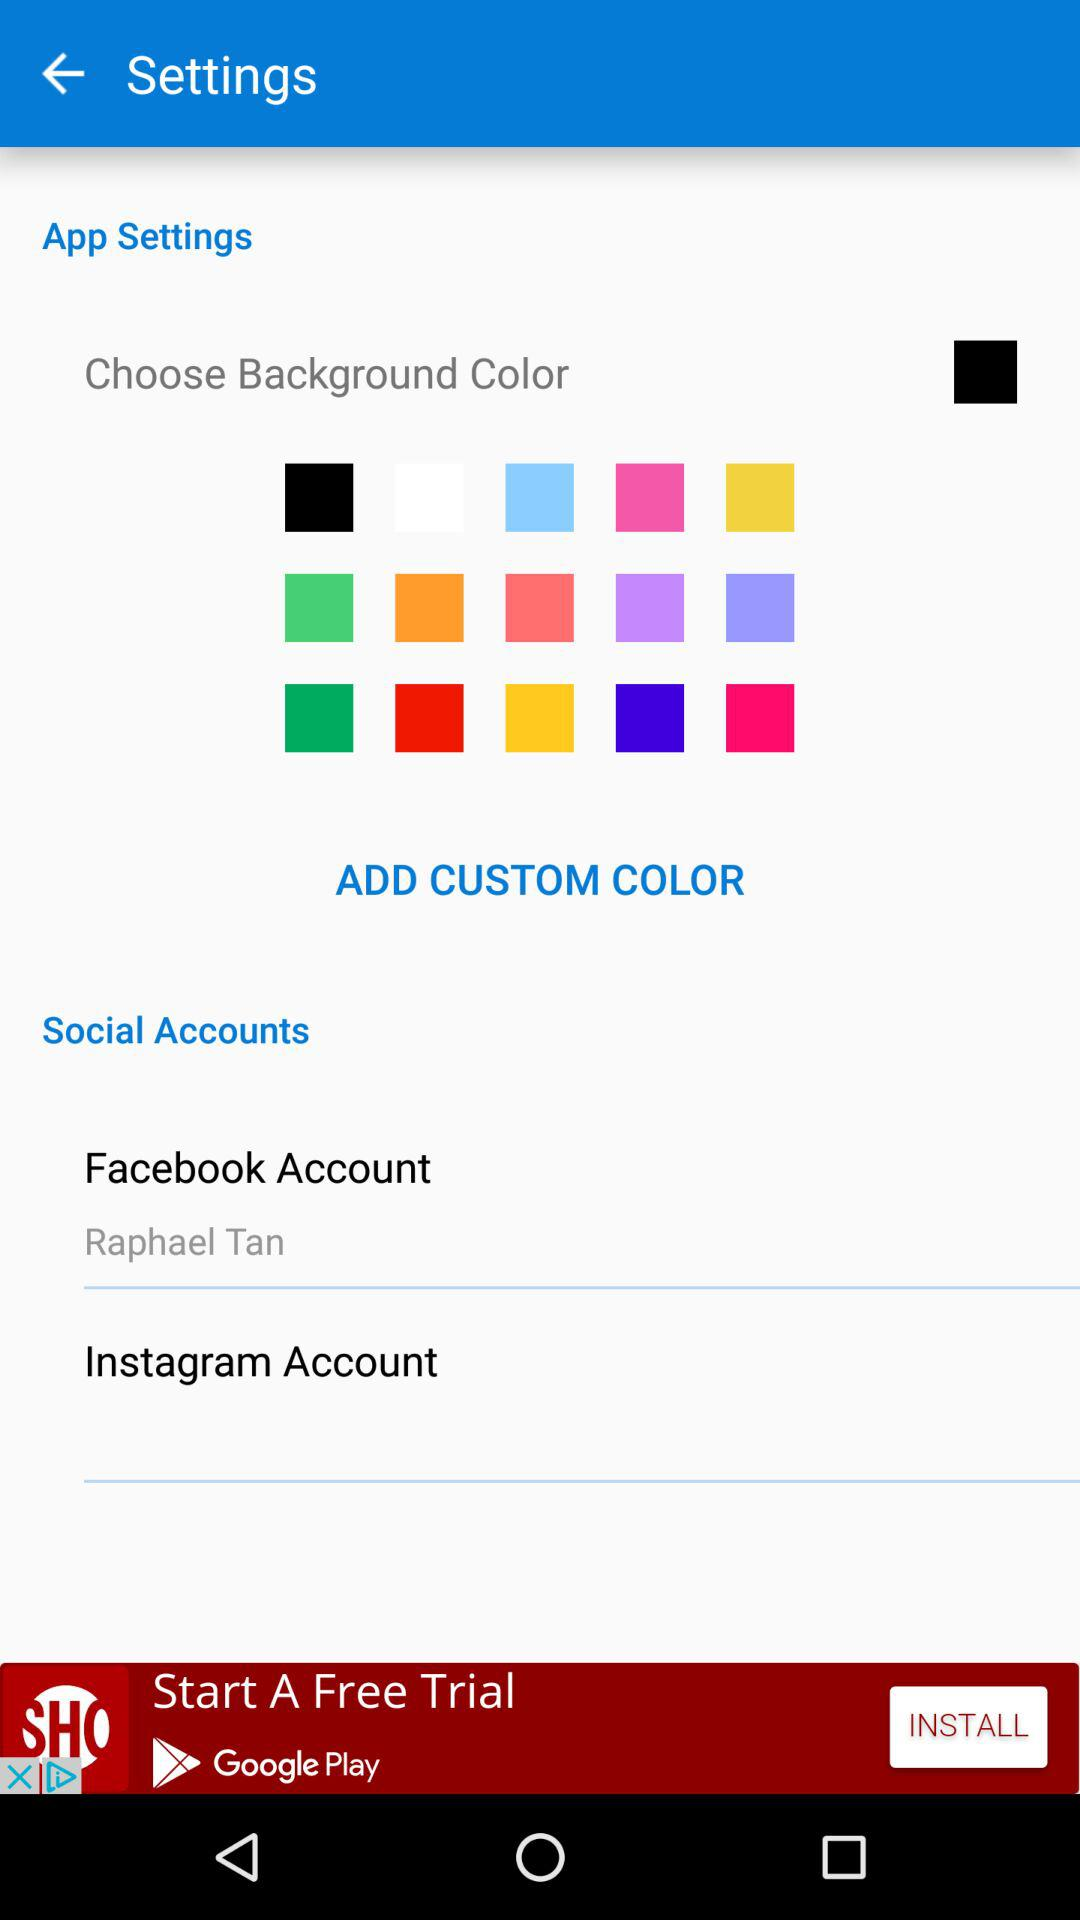Who has logged on to Facebook? The person who has logged on to Facebook is Raphael Tan. 